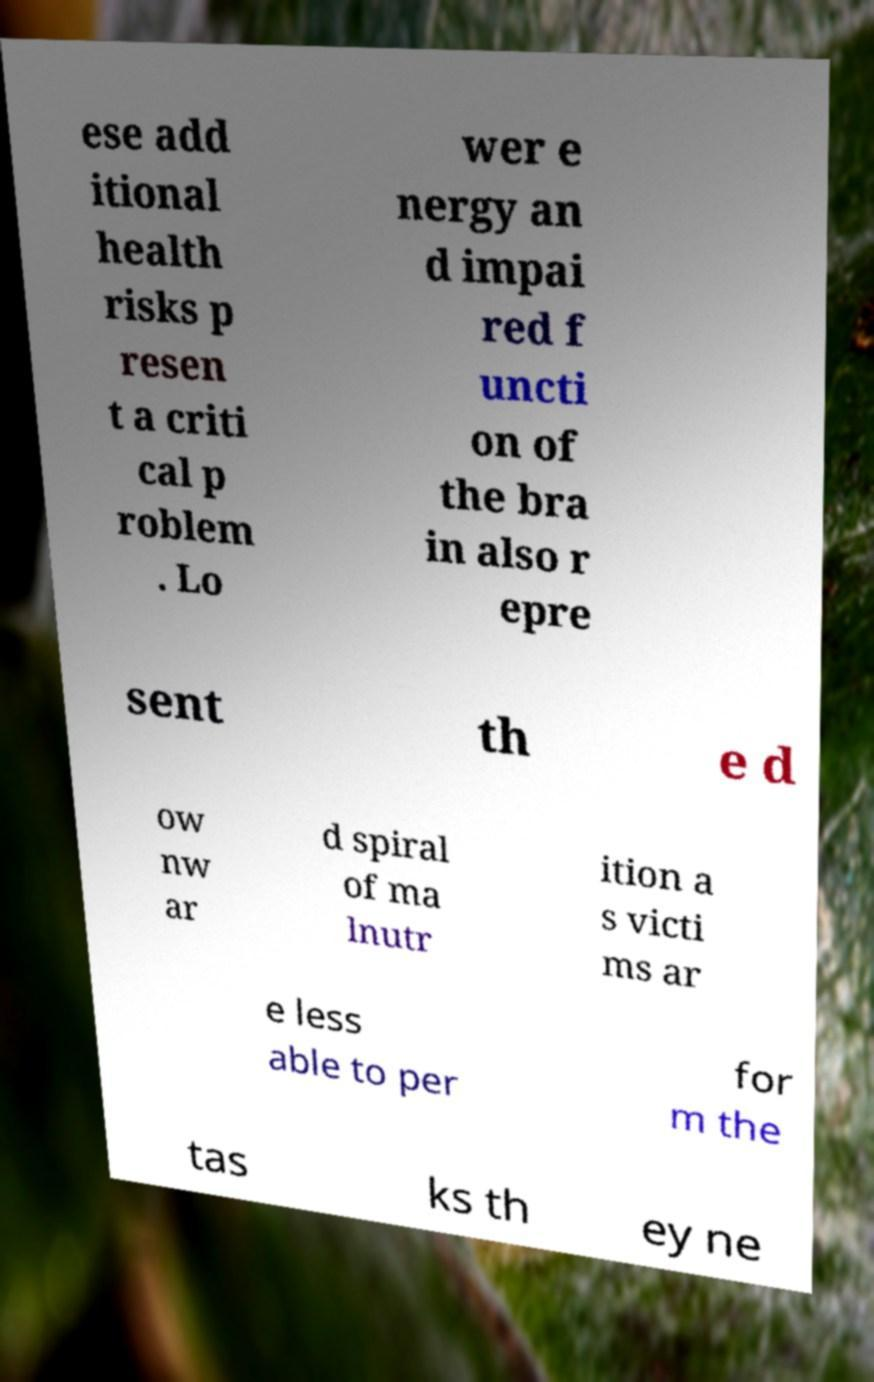For documentation purposes, I need the text within this image transcribed. Could you provide that? ese add itional health risks p resen t a criti cal p roblem . Lo wer e nergy an d impai red f uncti on of the bra in also r epre sent th e d ow nw ar d spiral of ma lnutr ition a s victi ms ar e less able to per for m the tas ks th ey ne 